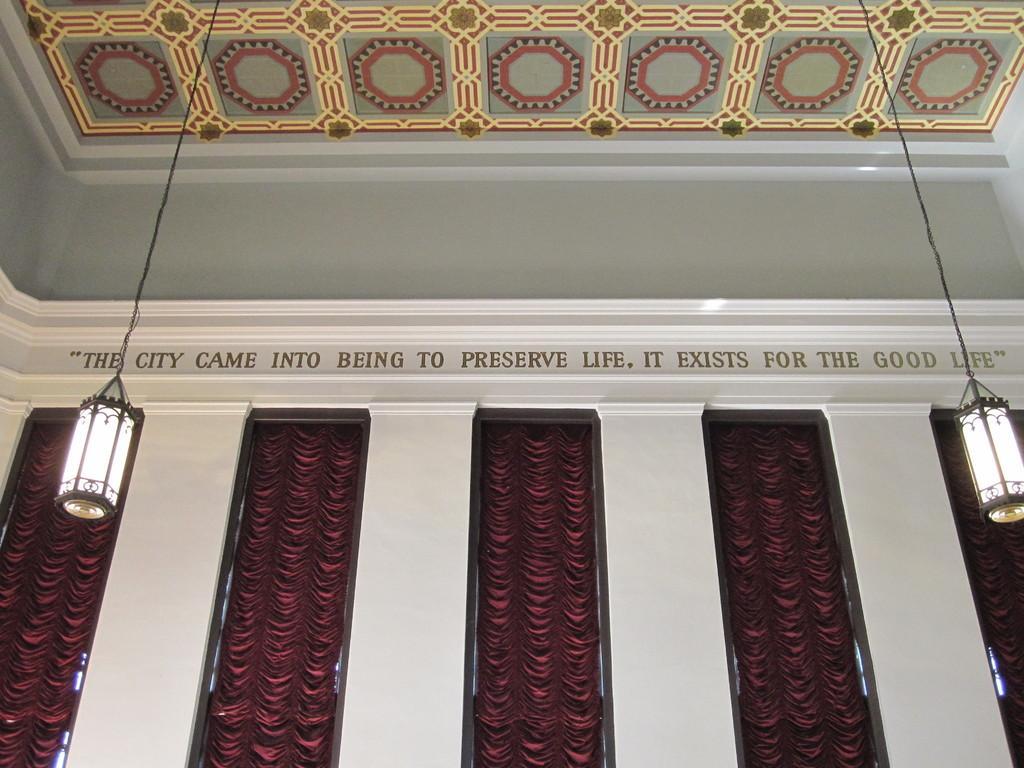In one or two sentences, can you explain what this image depicts? This is an inner view of a building. In this we can see a wall, roof, windows with curtains, two lamps hanged with a wire and some text on a wall. 